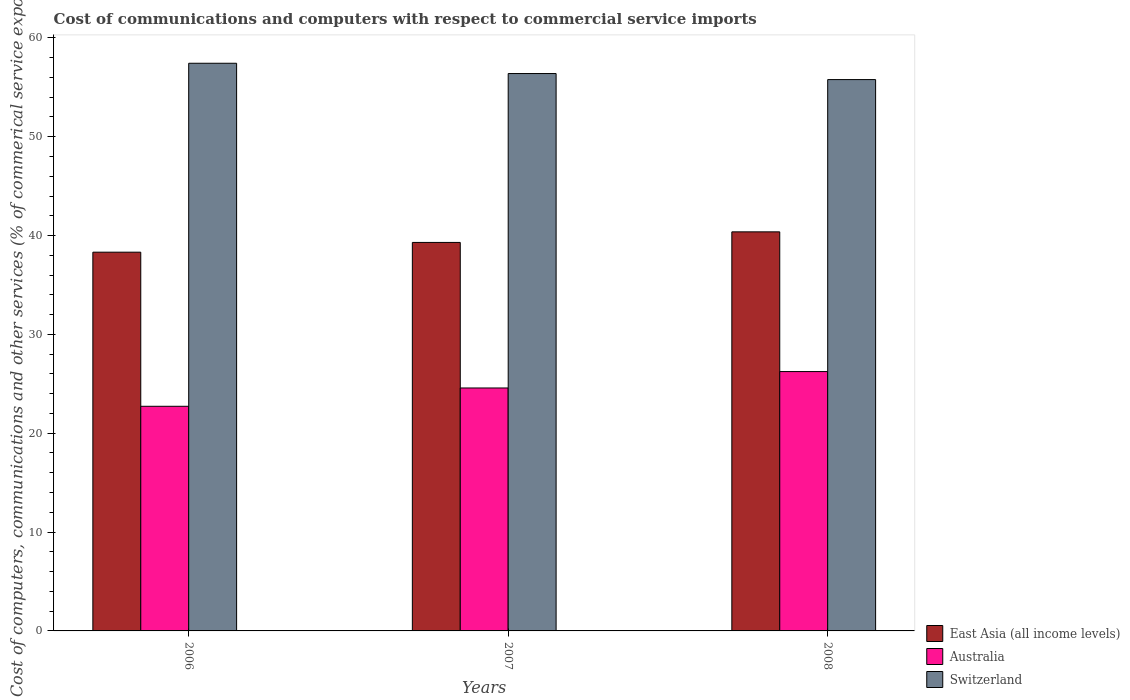How many different coloured bars are there?
Offer a terse response. 3. How many bars are there on the 2nd tick from the right?
Offer a terse response. 3. What is the label of the 1st group of bars from the left?
Your answer should be compact. 2006. In how many cases, is the number of bars for a given year not equal to the number of legend labels?
Ensure brevity in your answer.  0. What is the cost of communications and computers in East Asia (all income levels) in 2007?
Make the answer very short. 39.3. Across all years, what is the maximum cost of communications and computers in Australia?
Your answer should be very brief. 26.24. Across all years, what is the minimum cost of communications and computers in East Asia (all income levels)?
Ensure brevity in your answer.  38.32. What is the total cost of communications and computers in Australia in the graph?
Keep it short and to the point. 73.54. What is the difference between the cost of communications and computers in Switzerland in 2007 and that in 2008?
Your answer should be compact. 0.61. What is the difference between the cost of communications and computers in Australia in 2008 and the cost of communications and computers in East Asia (all income levels) in 2006?
Ensure brevity in your answer.  -12.08. What is the average cost of communications and computers in Australia per year?
Provide a succinct answer. 24.51. In the year 2006, what is the difference between the cost of communications and computers in Switzerland and cost of communications and computers in Australia?
Provide a succinct answer. 34.7. What is the ratio of the cost of communications and computers in East Asia (all income levels) in 2006 to that in 2007?
Ensure brevity in your answer.  0.97. What is the difference between the highest and the second highest cost of communications and computers in East Asia (all income levels)?
Offer a terse response. 1.07. What is the difference between the highest and the lowest cost of communications and computers in Switzerland?
Make the answer very short. 1.65. Is the sum of the cost of communications and computers in Australia in 2007 and 2008 greater than the maximum cost of communications and computers in East Asia (all income levels) across all years?
Your answer should be compact. Yes. What does the 1st bar from the left in 2007 represents?
Offer a very short reply. East Asia (all income levels). What does the 1st bar from the right in 2006 represents?
Your answer should be very brief. Switzerland. Are all the bars in the graph horizontal?
Provide a succinct answer. No. How many years are there in the graph?
Your response must be concise. 3. What is the difference between two consecutive major ticks on the Y-axis?
Make the answer very short. 10. Are the values on the major ticks of Y-axis written in scientific E-notation?
Offer a terse response. No. Does the graph contain any zero values?
Make the answer very short. No. Where does the legend appear in the graph?
Offer a very short reply. Bottom right. How many legend labels are there?
Provide a succinct answer. 3. How are the legend labels stacked?
Make the answer very short. Vertical. What is the title of the graph?
Your answer should be compact. Cost of communications and computers with respect to commercial service imports. What is the label or title of the X-axis?
Keep it short and to the point. Years. What is the label or title of the Y-axis?
Provide a succinct answer. Cost of computers, communications and other services (% of commerical service exports). What is the Cost of computers, communications and other services (% of commerical service exports) of East Asia (all income levels) in 2006?
Your response must be concise. 38.32. What is the Cost of computers, communications and other services (% of commerical service exports) of Australia in 2006?
Your answer should be compact. 22.72. What is the Cost of computers, communications and other services (% of commerical service exports) of Switzerland in 2006?
Provide a succinct answer. 57.43. What is the Cost of computers, communications and other services (% of commerical service exports) of East Asia (all income levels) in 2007?
Your answer should be very brief. 39.3. What is the Cost of computers, communications and other services (% of commerical service exports) of Australia in 2007?
Provide a succinct answer. 24.58. What is the Cost of computers, communications and other services (% of commerical service exports) in Switzerland in 2007?
Your answer should be compact. 56.39. What is the Cost of computers, communications and other services (% of commerical service exports) in East Asia (all income levels) in 2008?
Make the answer very short. 40.37. What is the Cost of computers, communications and other services (% of commerical service exports) in Australia in 2008?
Offer a very short reply. 26.24. What is the Cost of computers, communications and other services (% of commerical service exports) of Switzerland in 2008?
Keep it short and to the point. 55.78. Across all years, what is the maximum Cost of computers, communications and other services (% of commerical service exports) of East Asia (all income levels)?
Provide a short and direct response. 40.37. Across all years, what is the maximum Cost of computers, communications and other services (% of commerical service exports) in Australia?
Keep it short and to the point. 26.24. Across all years, what is the maximum Cost of computers, communications and other services (% of commerical service exports) of Switzerland?
Offer a terse response. 57.43. Across all years, what is the minimum Cost of computers, communications and other services (% of commerical service exports) in East Asia (all income levels)?
Your answer should be compact. 38.32. Across all years, what is the minimum Cost of computers, communications and other services (% of commerical service exports) of Australia?
Your response must be concise. 22.72. Across all years, what is the minimum Cost of computers, communications and other services (% of commerical service exports) of Switzerland?
Your answer should be compact. 55.78. What is the total Cost of computers, communications and other services (% of commerical service exports) of East Asia (all income levels) in the graph?
Give a very brief answer. 117.99. What is the total Cost of computers, communications and other services (% of commerical service exports) in Australia in the graph?
Keep it short and to the point. 73.54. What is the total Cost of computers, communications and other services (% of commerical service exports) in Switzerland in the graph?
Your answer should be compact. 169.6. What is the difference between the Cost of computers, communications and other services (% of commerical service exports) in East Asia (all income levels) in 2006 and that in 2007?
Your response must be concise. -0.99. What is the difference between the Cost of computers, communications and other services (% of commerical service exports) of Australia in 2006 and that in 2007?
Keep it short and to the point. -1.85. What is the difference between the Cost of computers, communications and other services (% of commerical service exports) in Switzerland in 2006 and that in 2007?
Ensure brevity in your answer.  1.04. What is the difference between the Cost of computers, communications and other services (% of commerical service exports) in East Asia (all income levels) in 2006 and that in 2008?
Offer a very short reply. -2.06. What is the difference between the Cost of computers, communications and other services (% of commerical service exports) of Australia in 2006 and that in 2008?
Give a very brief answer. -3.51. What is the difference between the Cost of computers, communications and other services (% of commerical service exports) in Switzerland in 2006 and that in 2008?
Provide a succinct answer. 1.65. What is the difference between the Cost of computers, communications and other services (% of commerical service exports) in East Asia (all income levels) in 2007 and that in 2008?
Provide a short and direct response. -1.07. What is the difference between the Cost of computers, communications and other services (% of commerical service exports) in Australia in 2007 and that in 2008?
Offer a terse response. -1.66. What is the difference between the Cost of computers, communications and other services (% of commerical service exports) of Switzerland in 2007 and that in 2008?
Your answer should be very brief. 0.61. What is the difference between the Cost of computers, communications and other services (% of commerical service exports) in East Asia (all income levels) in 2006 and the Cost of computers, communications and other services (% of commerical service exports) in Australia in 2007?
Your response must be concise. 13.74. What is the difference between the Cost of computers, communications and other services (% of commerical service exports) in East Asia (all income levels) in 2006 and the Cost of computers, communications and other services (% of commerical service exports) in Switzerland in 2007?
Provide a short and direct response. -18.07. What is the difference between the Cost of computers, communications and other services (% of commerical service exports) in Australia in 2006 and the Cost of computers, communications and other services (% of commerical service exports) in Switzerland in 2007?
Keep it short and to the point. -33.66. What is the difference between the Cost of computers, communications and other services (% of commerical service exports) of East Asia (all income levels) in 2006 and the Cost of computers, communications and other services (% of commerical service exports) of Australia in 2008?
Keep it short and to the point. 12.08. What is the difference between the Cost of computers, communications and other services (% of commerical service exports) in East Asia (all income levels) in 2006 and the Cost of computers, communications and other services (% of commerical service exports) in Switzerland in 2008?
Keep it short and to the point. -17.46. What is the difference between the Cost of computers, communications and other services (% of commerical service exports) in Australia in 2006 and the Cost of computers, communications and other services (% of commerical service exports) in Switzerland in 2008?
Keep it short and to the point. -33.05. What is the difference between the Cost of computers, communications and other services (% of commerical service exports) in East Asia (all income levels) in 2007 and the Cost of computers, communications and other services (% of commerical service exports) in Australia in 2008?
Keep it short and to the point. 13.06. What is the difference between the Cost of computers, communications and other services (% of commerical service exports) in East Asia (all income levels) in 2007 and the Cost of computers, communications and other services (% of commerical service exports) in Switzerland in 2008?
Provide a succinct answer. -16.48. What is the difference between the Cost of computers, communications and other services (% of commerical service exports) of Australia in 2007 and the Cost of computers, communications and other services (% of commerical service exports) of Switzerland in 2008?
Provide a succinct answer. -31.2. What is the average Cost of computers, communications and other services (% of commerical service exports) in East Asia (all income levels) per year?
Provide a succinct answer. 39.33. What is the average Cost of computers, communications and other services (% of commerical service exports) of Australia per year?
Offer a very short reply. 24.51. What is the average Cost of computers, communications and other services (% of commerical service exports) in Switzerland per year?
Offer a terse response. 56.53. In the year 2006, what is the difference between the Cost of computers, communications and other services (% of commerical service exports) in East Asia (all income levels) and Cost of computers, communications and other services (% of commerical service exports) in Australia?
Offer a terse response. 15.59. In the year 2006, what is the difference between the Cost of computers, communications and other services (% of commerical service exports) of East Asia (all income levels) and Cost of computers, communications and other services (% of commerical service exports) of Switzerland?
Give a very brief answer. -19.11. In the year 2006, what is the difference between the Cost of computers, communications and other services (% of commerical service exports) of Australia and Cost of computers, communications and other services (% of commerical service exports) of Switzerland?
Give a very brief answer. -34.7. In the year 2007, what is the difference between the Cost of computers, communications and other services (% of commerical service exports) in East Asia (all income levels) and Cost of computers, communications and other services (% of commerical service exports) in Australia?
Your answer should be very brief. 14.72. In the year 2007, what is the difference between the Cost of computers, communications and other services (% of commerical service exports) of East Asia (all income levels) and Cost of computers, communications and other services (% of commerical service exports) of Switzerland?
Provide a short and direct response. -17.09. In the year 2007, what is the difference between the Cost of computers, communications and other services (% of commerical service exports) of Australia and Cost of computers, communications and other services (% of commerical service exports) of Switzerland?
Your answer should be very brief. -31.81. In the year 2008, what is the difference between the Cost of computers, communications and other services (% of commerical service exports) of East Asia (all income levels) and Cost of computers, communications and other services (% of commerical service exports) of Australia?
Offer a very short reply. 14.14. In the year 2008, what is the difference between the Cost of computers, communications and other services (% of commerical service exports) of East Asia (all income levels) and Cost of computers, communications and other services (% of commerical service exports) of Switzerland?
Ensure brevity in your answer.  -15.4. In the year 2008, what is the difference between the Cost of computers, communications and other services (% of commerical service exports) of Australia and Cost of computers, communications and other services (% of commerical service exports) of Switzerland?
Keep it short and to the point. -29.54. What is the ratio of the Cost of computers, communications and other services (% of commerical service exports) in East Asia (all income levels) in 2006 to that in 2007?
Provide a succinct answer. 0.97. What is the ratio of the Cost of computers, communications and other services (% of commerical service exports) of Australia in 2006 to that in 2007?
Offer a very short reply. 0.92. What is the ratio of the Cost of computers, communications and other services (% of commerical service exports) of Switzerland in 2006 to that in 2007?
Ensure brevity in your answer.  1.02. What is the ratio of the Cost of computers, communications and other services (% of commerical service exports) in East Asia (all income levels) in 2006 to that in 2008?
Offer a terse response. 0.95. What is the ratio of the Cost of computers, communications and other services (% of commerical service exports) of Australia in 2006 to that in 2008?
Make the answer very short. 0.87. What is the ratio of the Cost of computers, communications and other services (% of commerical service exports) of Switzerland in 2006 to that in 2008?
Provide a short and direct response. 1.03. What is the ratio of the Cost of computers, communications and other services (% of commerical service exports) of East Asia (all income levels) in 2007 to that in 2008?
Your answer should be compact. 0.97. What is the ratio of the Cost of computers, communications and other services (% of commerical service exports) of Australia in 2007 to that in 2008?
Offer a terse response. 0.94. What is the difference between the highest and the second highest Cost of computers, communications and other services (% of commerical service exports) of East Asia (all income levels)?
Give a very brief answer. 1.07. What is the difference between the highest and the second highest Cost of computers, communications and other services (% of commerical service exports) of Australia?
Offer a very short reply. 1.66. What is the difference between the highest and the second highest Cost of computers, communications and other services (% of commerical service exports) in Switzerland?
Offer a very short reply. 1.04. What is the difference between the highest and the lowest Cost of computers, communications and other services (% of commerical service exports) of East Asia (all income levels)?
Offer a very short reply. 2.06. What is the difference between the highest and the lowest Cost of computers, communications and other services (% of commerical service exports) in Australia?
Give a very brief answer. 3.51. What is the difference between the highest and the lowest Cost of computers, communications and other services (% of commerical service exports) of Switzerland?
Keep it short and to the point. 1.65. 